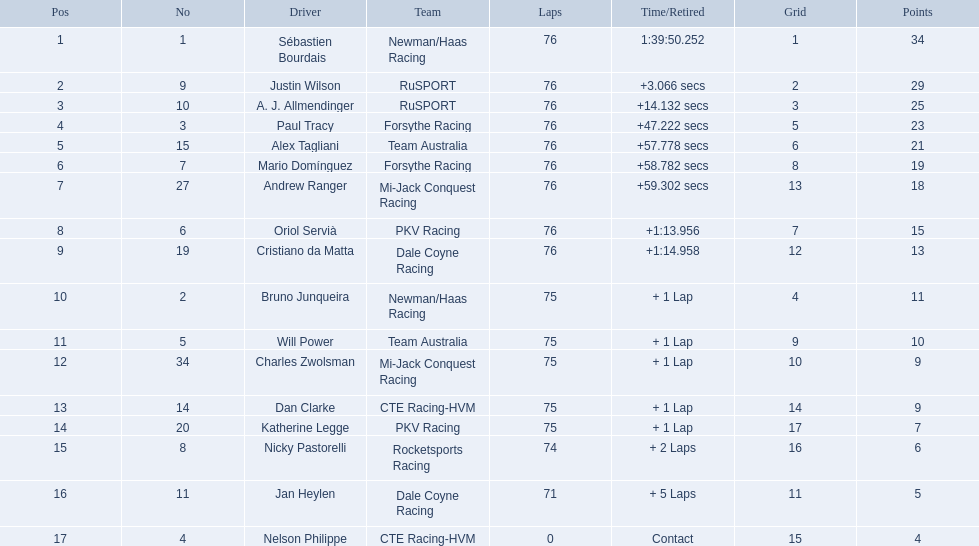Is there a driver named charles zwolsman? Charles Zwolsman. How many points did he acquire? 9. Were there any other entries that got the same number of points? 9. Who did that entry belong to? Dan Clarke. What was the concluding score for alex taglini in the tecate grand prix? 21. What was the end score for paul tracy in the same race? 23. Which racer came in first place? Paul Tracy. 